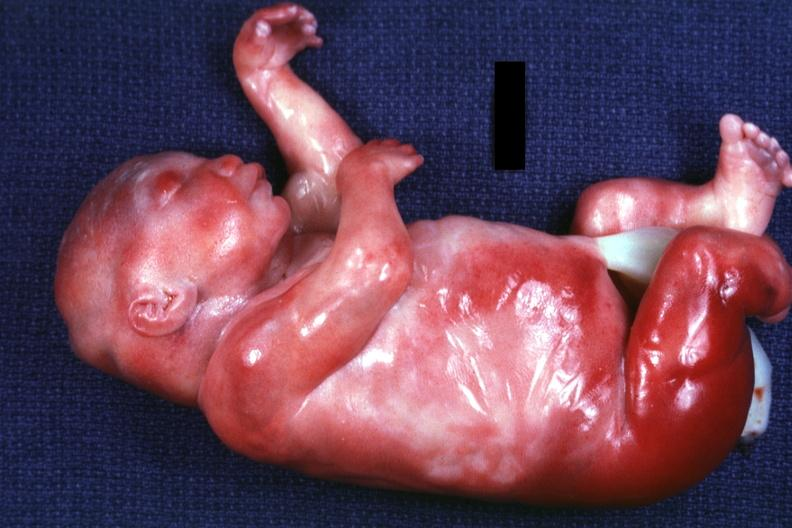s acid of kidneys present?
Answer the question using a single word or phrase. No 